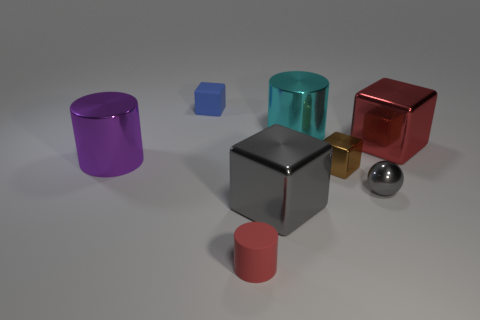Subtract 2 blocks. How many blocks are left? 2 Add 2 large cyan metallic things. How many objects exist? 10 Subtract all cyan cylinders. Subtract all green balls. How many cylinders are left? 2 Subtract all cylinders. How many objects are left? 5 Add 2 cyan metal cylinders. How many cyan metal cylinders exist? 3 Subtract 0 green spheres. How many objects are left? 8 Subtract all rubber things. Subtract all red rubber cylinders. How many objects are left? 5 Add 3 small brown metal objects. How many small brown metal objects are left? 4 